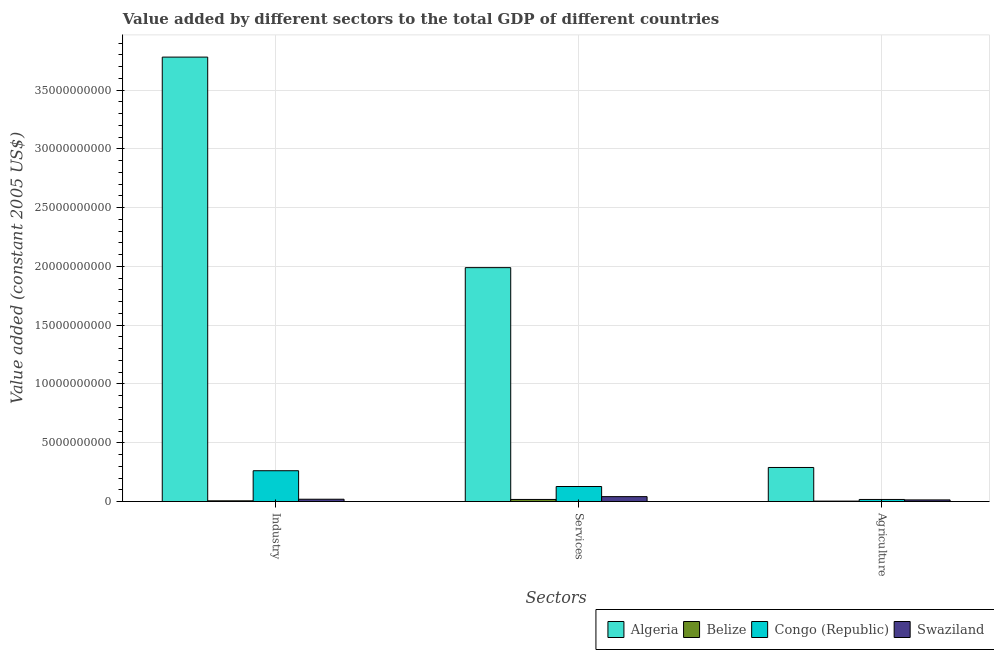How many different coloured bars are there?
Make the answer very short. 4. Are the number of bars per tick equal to the number of legend labels?
Keep it short and to the point. Yes. Are the number of bars on each tick of the X-axis equal?
Offer a very short reply. Yes. How many bars are there on the 3rd tick from the left?
Ensure brevity in your answer.  4. What is the label of the 3rd group of bars from the left?
Ensure brevity in your answer.  Agriculture. What is the value added by industrial sector in Swaziland?
Make the answer very short. 1.99e+08. Across all countries, what is the maximum value added by services?
Offer a terse response. 1.99e+1. Across all countries, what is the minimum value added by services?
Offer a very short reply. 1.80e+08. In which country was the value added by industrial sector maximum?
Provide a short and direct response. Algeria. In which country was the value added by services minimum?
Your answer should be compact. Belize. What is the total value added by services in the graph?
Your answer should be compact. 2.18e+1. What is the difference between the value added by industrial sector in Swaziland and that in Belize?
Provide a short and direct response. 1.36e+08. What is the difference between the value added by agricultural sector in Belize and the value added by industrial sector in Congo (Republic)?
Ensure brevity in your answer.  -2.58e+09. What is the average value added by services per country?
Offer a very short reply. 5.44e+09. What is the difference between the value added by industrial sector and value added by agricultural sector in Congo (Republic)?
Make the answer very short. 2.44e+09. In how many countries, is the value added by services greater than 12000000000 US$?
Your response must be concise. 1. What is the ratio of the value added by industrial sector in Swaziland to that in Belize?
Keep it short and to the point. 3.15. Is the value added by services in Swaziland less than that in Belize?
Offer a very short reply. No. What is the difference between the highest and the second highest value added by agricultural sector?
Offer a very short reply. 2.72e+09. What is the difference between the highest and the lowest value added by services?
Provide a succinct answer. 1.97e+1. In how many countries, is the value added by industrial sector greater than the average value added by industrial sector taken over all countries?
Provide a succinct answer. 1. Is the sum of the value added by agricultural sector in Belize and Swaziland greater than the maximum value added by services across all countries?
Give a very brief answer. No. What does the 1st bar from the left in Industry represents?
Your response must be concise. Algeria. What does the 3rd bar from the right in Industry represents?
Provide a short and direct response. Belize. How many bars are there?
Give a very brief answer. 12. Are all the bars in the graph horizontal?
Make the answer very short. No. How many countries are there in the graph?
Ensure brevity in your answer.  4. What is the difference between two consecutive major ticks on the Y-axis?
Your answer should be compact. 5.00e+09. Does the graph contain grids?
Offer a very short reply. Yes. What is the title of the graph?
Make the answer very short. Value added by different sectors to the total GDP of different countries. Does "Ukraine" appear as one of the legend labels in the graph?
Your answer should be very brief. No. What is the label or title of the X-axis?
Make the answer very short. Sectors. What is the label or title of the Y-axis?
Provide a succinct answer. Value added (constant 2005 US$). What is the Value added (constant 2005 US$) in Algeria in Industry?
Keep it short and to the point. 3.78e+1. What is the Value added (constant 2005 US$) of Belize in Industry?
Provide a succinct answer. 6.33e+07. What is the Value added (constant 2005 US$) in Congo (Republic) in Industry?
Provide a succinct answer. 2.62e+09. What is the Value added (constant 2005 US$) of Swaziland in Industry?
Offer a terse response. 1.99e+08. What is the Value added (constant 2005 US$) in Algeria in Services?
Your response must be concise. 1.99e+1. What is the Value added (constant 2005 US$) of Belize in Services?
Your answer should be compact. 1.80e+08. What is the Value added (constant 2005 US$) in Congo (Republic) in Services?
Provide a succinct answer. 1.28e+09. What is the Value added (constant 2005 US$) in Swaziland in Services?
Make the answer very short. 4.19e+08. What is the Value added (constant 2005 US$) in Algeria in Agriculture?
Give a very brief answer. 2.90e+09. What is the Value added (constant 2005 US$) in Belize in Agriculture?
Make the answer very short. 3.89e+07. What is the Value added (constant 2005 US$) in Congo (Republic) in Agriculture?
Offer a terse response. 1.79e+08. What is the Value added (constant 2005 US$) of Swaziland in Agriculture?
Offer a very short reply. 1.40e+08. Across all Sectors, what is the maximum Value added (constant 2005 US$) of Algeria?
Offer a very short reply. 3.78e+1. Across all Sectors, what is the maximum Value added (constant 2005 US$) in Belize?
Offer a terse response. 1.80e+08. Across all Sectors, what is the maximum Value added (constant 2005 US$) in Congo (Republic)?
Offer a very short reply. 2.62e+09. Across all Sectors, what is the maximum Value added (constant 2005 US$) in Swaziland?
Make the answer very short. 4.19e+08. Across all Sectors, what is the minimum Value added (constant 2005 US$) of Algeria?
Your response must be concise. 2.90e+09. Across all Sectors, what is the minimum Value added (constant 2005 US$) in Belize?
Ensure brevity in your answer.  3.89e+07. Across all Sectors, what is the minimum Value added (constant 2005 US$) in Congo (Republic)?
Provide a succinct answer. 1.79e+08. Across all Sectors, what is the minimum Value added (constant 2005 US$) of Swaziland?
Your answer should be very brief. 1.40e+08. What is the total Value added (constant 2005 US$) of Algeria in the graph?
Ensure brevity in your answer.  6.06e+1. What is the total Value added (constant 2005 US$) in Belize in the graph?
Ensure brevity in your answer.  2.82e+08. What is the total Value added (constant 2005 US$) in Congo (Republic) in the graph?
Provide a succinct answer. 4.08e+09. What is the total Value added (constant 2005 US$) of Swaziland in the graph?
Your response must be concise. 7.58e+08. What is the difference between the Value added (constant 2005 US$) in Algeria in Industry and that in Services?
Your answer should be compact. 1.79e+1. What is the difference between the Value added (constant 2005 US$) of Belize in Industry and that in Services?
Offer a terse response. -1.16e+08. What is the difference between the Value added (constant 2005 US$) of Congo (Republic) in Industry and that in Services?
Your answer should be compact. 1.34e+09. What is the difference between the Value added (constant 2005 US$) of Swaziland in Industry and that in Services?
Ensure brevity in your answer.  -2.20e+08. What is the difference between the Value added (constant 2005 US$) of Algeria in Industry and that in Agriculture?
Your answer should be compact. 3.49e+1. What is the difference between the Value added (constant 2005 US$) in Belize in Industry and that in Agriculture?
Offer a terse response. 2.44e+07. What is the difference between the Value added (constant 2005 US$) in Congo (Republic) in Industry and that in Agriculture?
Your answer should be compact. 2.44e+09. What is the difference between the Value added (constant 2005 US$) of Swaziland in Industry and that in Agriculture?
Make the answer very short. 5.96e+07. What is the difference between the Value added (constant 2005 US$) in Algeria in Services and that in Agriculture?
Offer a very short reply. 1.70e+1. What is the difference between the Value added (constant 2005 US$) in Belize in Services and that in Agriculture?
Your answer should be compact. 1.41e+08. What is the difference between the Value added (constant 2005 US$) in Congo (Republic) in Services and that in Agriculture?
Provide a succinct answer. 1.10e+09. What is the difference between the Value added (constant 2005 US$) of Swaziland in Services and that in Agriculture?
Your answer should be compact. 2.80e+08. What is the difference between the Value added (constant 2005 US$) of Algeria in Industry and the Value added (constant 2005 US$) of Belize in Services?
Offer a terse response. 3.76e+1. What is the difference between the Value added (constant 2005 US$) of Algeria in Industry and the Value added (constant 2005 US$) of Congo (Republic) in Services?
Your response must be concise. 3.65e+1. What is the difference between the Value added (constant 2005 US$) of Algeria in Industry and the Value added (constant 2005 US$) of Swaziland in Services?
Your answer should be very brief. 3.74e+1. What is the difference between the Value added (constant 2005 US$) in Belize in Industry and the Value added (constant 2005 US$) in Congo (Republic) in Services?
Make the answer very short. -1.22e+09. What is the difference between the Value added (constant 2005 US$) of Belize in Industry and the Value added (constant 2005 US$) of Swaziland in Services?
Give a very brief answer. -3.56e+08. What is the difference between the Value added (constant 2005 US$) in Congo (Republic) in Industry and the Value added (constant 2005 US$) in Swaziland in Services?
Provide a short and direct response. 2.20e+09. What is the difference between the Value added (constant 2005 US$) in Algeria in Industry and the Value added (constant 2005 US$) in Belize in Agriculture?
Your answer should be compact. 3.78e+1. What is the difference between the Value added (constant 2005 US$) of Algeria in Industry and the Value added (constant 2005 US$) of Congo (Republic) in Agriculture?
Provide a succinct answer. 3.76e+1. What is the difference between the Value added (constant 2005 US$) in Algeria in Industry and the Value added (constant 2005 US$) in Swaziland in Agriculture?
Ensure brevity in your answer.  3.77e+1. What is the difference between the Value added (constant 2005 US$) in Belize in Industry and the Value added (constant 2005 US$) in Congo (Republic) in Agriculture?
Your answer should be compact. -1.16e+08. What is the difference between the Value added (constant 2005 US$) of Belize in Industry and the Value added (constant 2005 US$) of Swaziland in Agriculture?
Offer a terse response. -7.64e+07. What is the difference between the Value added (constant 2005 US$) in Congo (Republic) in Industry and the Value added (constant 2005 US$) in Swaziland in Agriculture?
Provide a short and direct response. 2.48e+09. What is the difference between the Value added (constant 2005 US$) in Algeria in Services and the Value added (constant 2005 US$) in Belize in Agriculture?
Offer a very short reply. 1.99e+1. What is the difference between the Value added (constant 2005 US$) in Algeria in Services and the Value added (constant 2005 US$) in Congo (Republic) in Agriculture?
Your response must be concise. 1.97e+1. What is the difference between the Value added (constant 2005 US$) in Algeria in Services and the Value added (constant 2005 US$) in Swaziland in Agriculture?
Provide a succinct answer. 1.98e+1. What is the difference between the Value added (constant 2005 US$) in Belize in Services and the Value added (constant 2005 US$) in Congo (Republic) in Agriculture?
Provide a short and direct response. 5.04e+05. What is the difference between the Value added (constant 2005 US$) in Belize in Services and the Value added (constant 2005 US$) in Swaziland in Agriculture?
Make the answer very short. 4.00e+07. What is the difference between the Value added (constant 2005 US$) of Congo (Republic) in Services and the Value added (constant 2005 US$) of Swaziland in Agriculture?
Provide a short and direct response. 1.14e+09. What is the average Value added (constant 2005 US$) of Algeria per Sectors?
Keep it short and to the point. 2.02e+1. What is the average Value added (constant 2005 US$) of Belize per Sectors?
Offer a terse response. 9.40e+07. What is the average Value added (constant 2005 US$) of Congo (Republic) per Sectors?
Ensure brevity in your answer.  1.36e+09. What is the average Value added (constant 2005 US$) of Swaziland per Sectors?
Offer a terse response. 2.53e+08. What is the difference between the Value added (constant 2005 US$) of Algeria and Value added (constant 2005 US$) of Belize in Industry?
Make the answer very short. 3.77e+1. What is the difference between the Value added (constant 2005 US$) of Algeria and Value added (constant 2005 US$) of Congo (Republic) in Industry?
Provide a short and direct response. 3.52e+1. What is the difference between the Value added (constant 2005 US$) in Algeria and Value added (constant 2005 US$) in Swaziland in Industry?
Give a very brief answer. 3.76e+1. What is the difference between the Value added (constant 2005 US$) of Belize and Value added (constant 2005 US$) of Congo (Republic) in Industry?
Provide a succinct answer. -2.56e+09. What is the difference between the Value added (constant 2005 US$) of Belize and Value added (constant 2005 US$) of Swaziland in Industry?
Offer a terse response. -1.36e+08. What is the difference between the Value added (constant 2005 US$) in Congo (Republic) and Value added (constant 2005 US$) in Swaziland in Industry?
Ensure brevity in your answer.  2.42e+09. What is the difference between the Value added (constant 2005 US$) of Algeria and Value added (constant 2005 US$) of Belize in Services?
Offer a very short reply. 1.97e+1. What is the difference between the Value added (constant 2005 US$) in Algeria and Value added (constant 2005 US$) in Congo (Republic) in Services?
Your response must be concise. 1.86e+1. What is the difference between the Value added (constant 2005 US$) of Algeria and Value added (constant 2005 US$) of Swaziland in Services?
Offer a very short reply. 1.95e+1. What is the difference between the Value added (constant 2005 US$) of Belize and Value added (constant 2005 US$) of Congo (Republic) in Services?
Offer a very short reply. -1.10e+09. What is the difference between the Value added (constant 2005 US$) in Belize and Value added (constant 2005 US$) in Swaziland in Services?
Your answer should be very brief. -2.40e+08. What is the difference between the Value added (constant 2005 US$) in Congo (Republic) and Value added (constant 2005 US$) in Swaziland in Services?
Make the answer very short. 8.61e+08. What is the difference between the Value added (constant 2005 US$) in Algeria and Value added (constant 2005 US$) in Belize in Agriculture?
Provide a short and direct response. 2.86e+09. What is the difference between the Value added (constant 2005 US$) in Algeria and Value added (constant 2005 US$) in Congo (Republic) in Agriculture?
Ensure brevity in your answer.  2.72e+09. What is the difference between the Value added (constant 2005 US$) in Algeria and Value added (constant 2005 US$) in Swaziland in Agriculture?
Give a very brief answer. 2.76e+09. What is the difference between the Value added (constant 2005 US$) of Belize and Value added (constant 2005 US$) of Congo (Republic) in Agriculture?
Your answer should be compact. -1.40e+08. What is the difference between the Value added (constant 2005 US$) in Belize and Value added (constant 2005 US$) in Swaziland in Agriculture?
Your answer should be very brief. -1.01e+08. What is the difference between the Value added (constant 2005 US$) of Congo (Republic) and Value added (constant 2005 US$) of Swaziland in Agriculture?
Ensure brevity in your answer.  3.95e+07. What is the ratio of the Value added (constant 2005 US$) of Belize in Industry to that in Services?
Give a very brief answer. 0.35. What is the ratio of the Value added (constant 2005 US$) of Congo (Republic) in Industry to that in Services?
Your answer should be compact. 2.05. What is the ratio of the Value added (constant 2005 US$) in Swaziland in Industry to that in Services?
Provide a succinct answer. 0.48. What is the ratio of the Value added (constant 2005 US$) of Algeria in Industry to that in Agriculture?
Keep it short and to the point. 13.04. What is the ratio of the Value added (constant 2005 US$) in Belize in Industry to that in Agriculture?
Keep it short and to the point. 1.63. What is the ratio of the Value added (constant 2005 US$) of Congo (Republic) in Industry to that in Agriculture?
Ensure brevity in your answer.  14.64. What is the ratio of the Value added (constant 2005 US$) in Swaziland in Industry to that in Agriculture?
Provide a short and direct response. 1.43. What is the ratio of the Value added (constant 2005 US$) in Algeria in Services to that in Agriculture?
Ensure brevity in your answer.  6.86. What is the ratio of the Value added (constant 2005 US$) of Belize in Services to that in Agriculture?
Your answer should be compact. 4.62. What is the ratio of the Value added (constant 2005 US$) of Congo (Republic) in Services to that in Agriculture?
Provide a succinct answer. 7.15. What is the ratio of the Value added (constant 2005 US$) of Swaziland in Services to that in Agriculture?
Provide a succinct answer. 3. What is the difference between the highest and the second highest Value added (constant 2005 US$) of Algeria?
Give a very brief answer. 1.79e+1. What is the difference between the highest and the second highest Value added (constant 2005 US$) in Belize?
Provide a succinct answer. 1.16e+08. What is the difference between the highest and the second highest Value added (constant 2005 US$) in Congo (Republic)?
Provide a short and direct response. 1.34e+09. What is the difference between the highest and the second highest Value added (constant 2005 US$) of Swaziland?
Ensure brevity in your answer.  2.20e+08. What is the difference between the highest and the lowest Value added (constant 2005 US$) of Algeria?
Your answer should be very brief. 3.49e+1. What is the difference between the highest and the lowest Value added (constant 2005 US$) in Belize?
Your answer should be very brief. 1.41e+08. What is the difference between the highest and the lowest Value added (constant 2005 US$) of Congo (Republic)?
Keep it short and to the point. 2.44e+09. What is the difference between the highest and the lowest Value added (constant 2005 US$) in Swaziland?
Ensure brevity in your answer.  2.80e+08. 